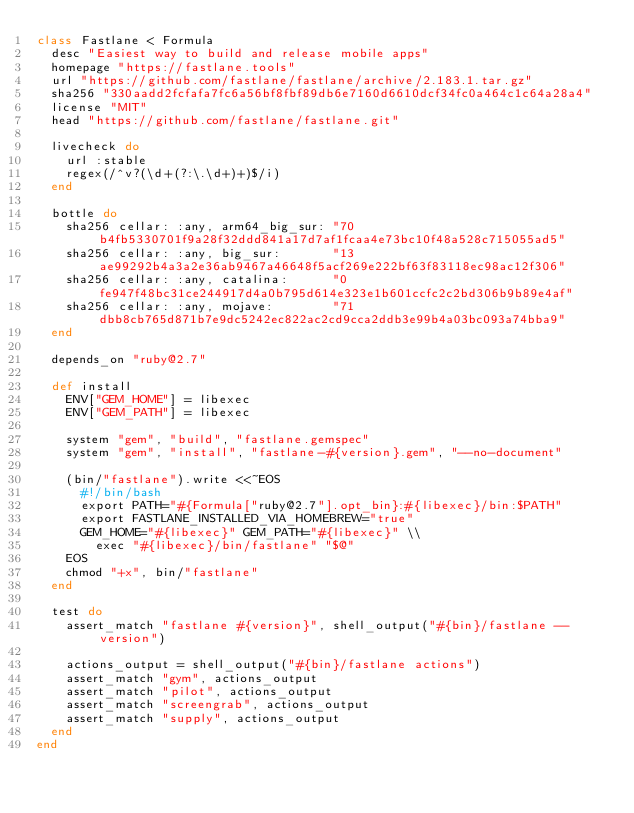<code> <loc_0><loc_0><loc_500><loc_500><_Ruby_>class Fastlane < Formula
  desc "Easiest way to build and release mobile apps"
  homepage "https://fastlane.tools"
  url "https://github.com/fastlane/fastlane/archive/2.183.1.tar.gz"
  sha256 "330aadd2fcfafa7fc6a56bf8fbf89db6e7160d6610dcf34fc0a464c1c64a28a4"
  license "MIT"
  head "https://github.com/fastlane/fastlane.git"

  livecheck do
    url :stable
    regex(/^v?(\d+(?:\.\d+)+)$/i)
  end

  bottle do
    sha256 cellar: :any, arm64_big_sur: "70b4fb5330701f9a28f32ddd841a17d7af1fcaa4e73bc10f48a528c715055ad5"
    sha256 cellar: :any, big_sur:       "13ae99292b4a3a2e36ab9467a46648f5acf269e222bf63f83118ec98ac12f306"
    sha256 cellar: :any, catalina:      "0fe947f48bc31ce244917d4a0b795d614e323e1b601ccfc2c2bd306b9b89e4af"
    sha256 cellar: :any, mojave:        "71dbb8cb765d871b7e9dc5242ec822ac2cd9cca2ddb3e99b4a03bc093a74bba9"
  end

  depends_on "ruby@2.7"

  def install
    ENV["GEM_HOME"] = libexec
    ENV["GEM_PATH"] = libexec

    system "gem", "build", "fastlane.gemspec"
    system "gem", "install", "fastlane-#{version}.gem", "--no-document"

    (bin/"fastlane").write <<~EOS
      #!/bin/bash
      export PATH="#{Formula["ruby@2.7"].opt_bin}:#{libexec}/bin:$PATH"
      export FASTLANE_INSTALLED_VIA_HOMEBREW="true"
      GEM_HOME="#{libexec}" GEM_PATH="#{libexec}" \\
        exec "#{libexec}/bin/fastlane" "$@"
    EOS
    chmod "+x", bin/"fastlane"
  end

  test do
    assert_match "fastlane #{version}", shell_output("#{bin}/fastlane --version")

    actions_output = shell_output("#{bin}/fastlane actions")
    assert_match "gym", actions_output
    assert_match "pilot", actions_output
    assert_match "screengrab", actions_output
    assert_match "supply", actions_output
  end
end
</code> 